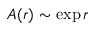Convert formula to latex. <formula><loc_0><loc_0><loc_500><loc_500>A ( r ) \sim \exp r</formula> 